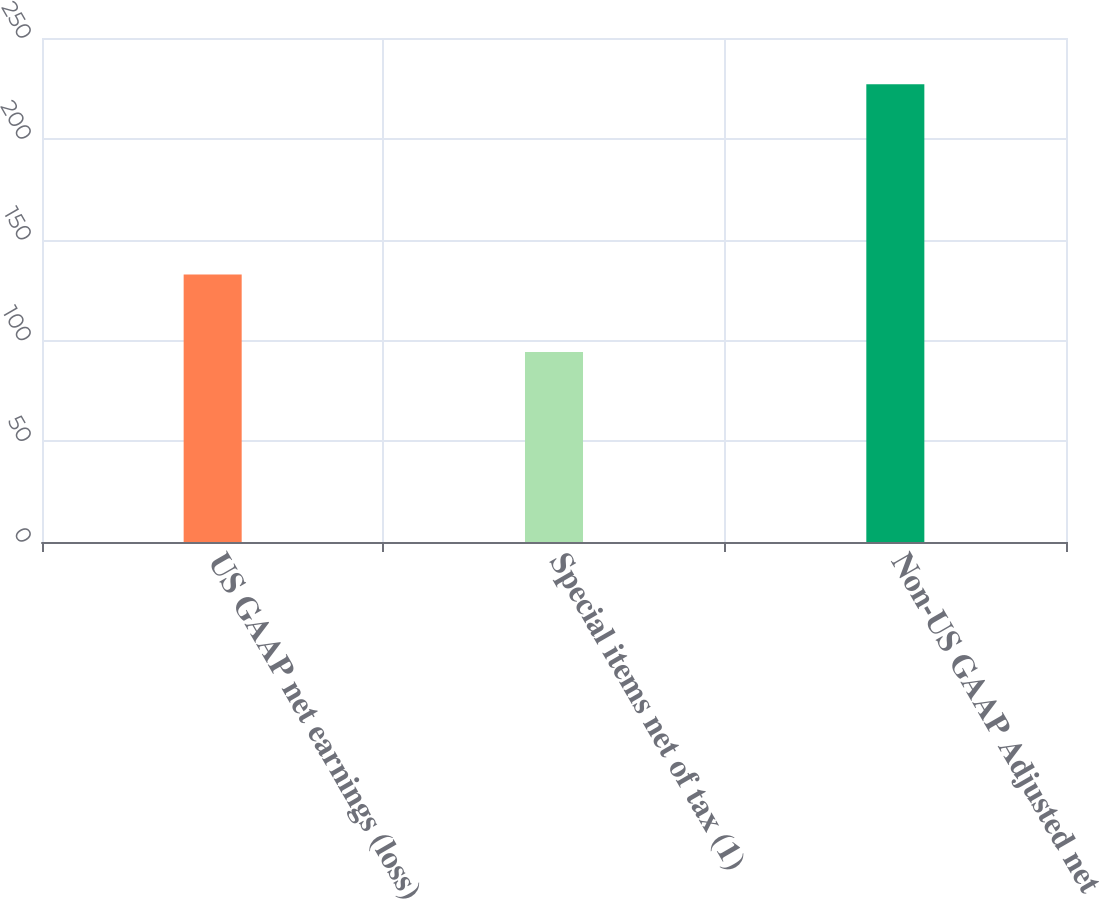Convert chart to OTSL. <chart><loc_0><loc_0><loc_500><loc_500><bar_chart><fcel>US GAAP net earnings (loss)<fcel>Special items net of tax (1)<fcel>Non-US GAAP Adjusted net<nl><fcel>132.7<fcel>94.3<fcel>227<nl></chart> 